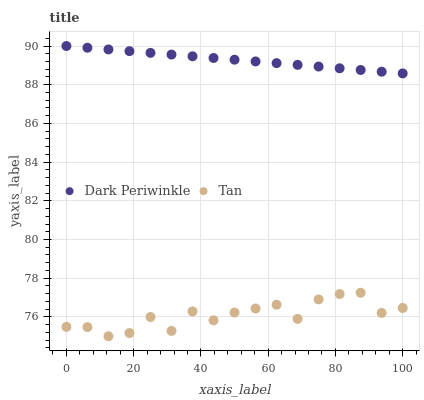Does Tan have the minimum area under the curve?
Answer yes or no. Yes. Does Dark Periwinkle have the maximum area under the curve?
Answer yes or no. Yes. Does Dark Periwinkle have the minimum area under the curve?
Answer yes or no. No. Is Dark Periwinkle the smoothest?
Answer yes or no. Yes. Is Tan the roughest?
Answer yes or no. Yes. Is Dark Periwinkle the roughest?
Answer yes or no. No. Does Tan have the lowest value?
Answer yes or no. Yes. Does Dark Periwinkle have the lowest value?
Answer yes or no. No. Does Dark Periwinkle have the highest value?
Answer yes or no. Yes. Is Tan less than Dark Periwinkle?
Answer yes or no. Yes. Is Dark Periwinkle greater than Tan?
Answer yes or no. Yes. Does Tan intersect Dark Periwinkle?
Answer yes or no. No. 